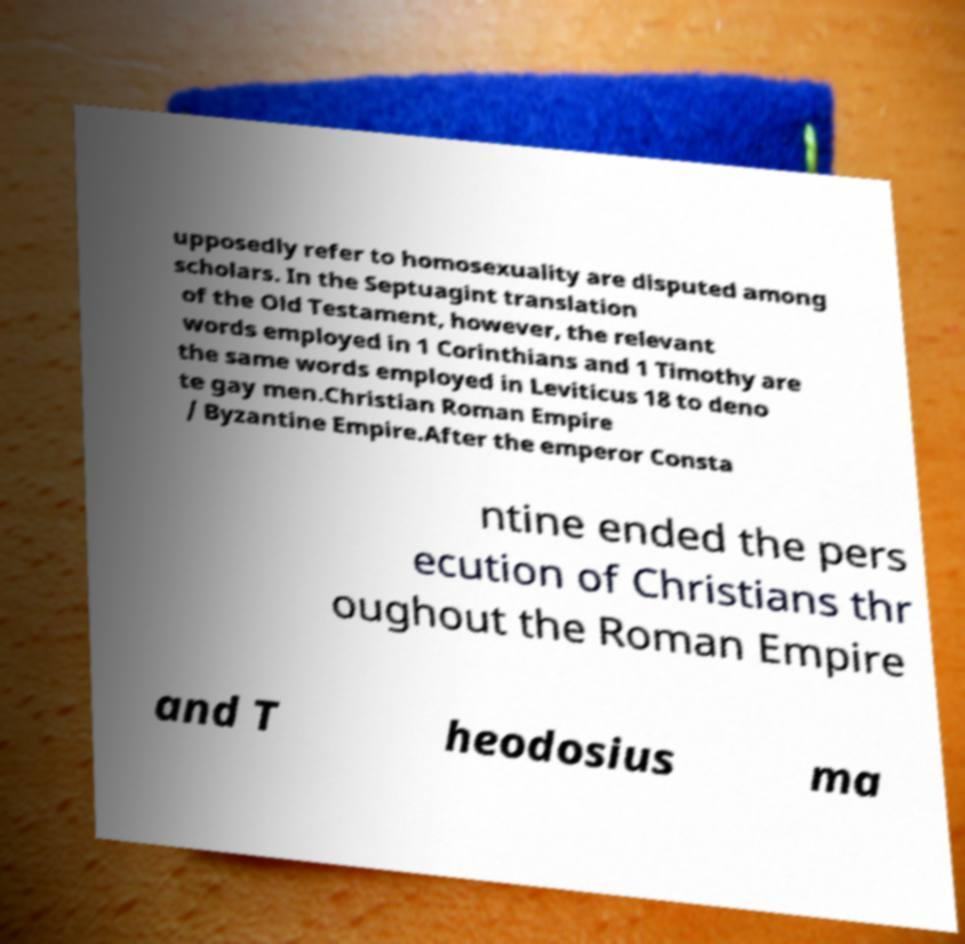I need the written content from this picture converted into text. Can you do that? upposedly refer to homosexuality are disputed among scholars. In the Septuagint translation of the Old Testament, however, the relevant words employed in 1 Corinthians and 1 Timothy are the same words employed in Leviticus 18 to deno te gay men.Christian Roman Empire / Byzantine Empire.After the emperor Consta ntine ended the pers ecution of Christians thr oughout the Roman Empire and T heodosius ma 